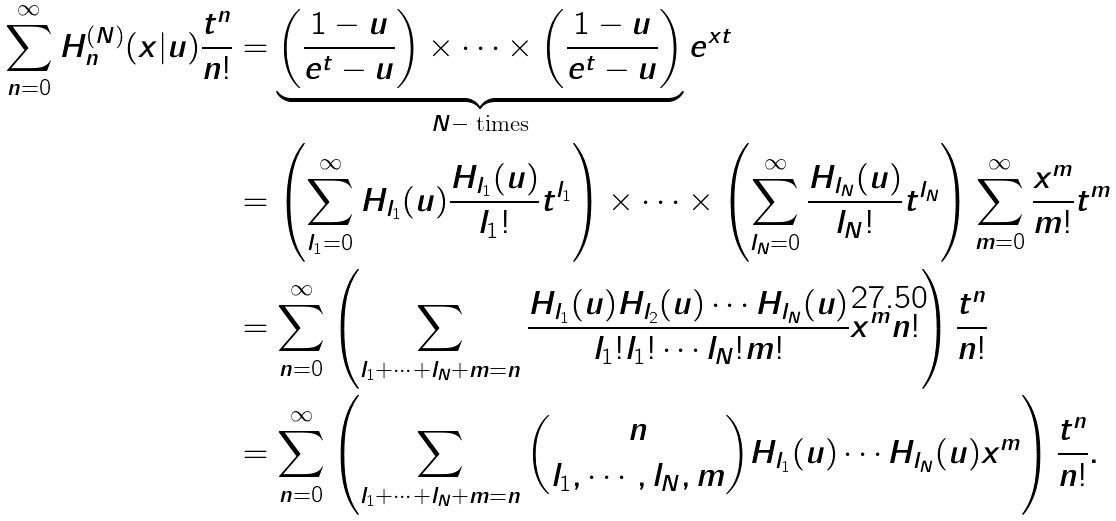Convert formula to latex. <formula><loc_0><loc_0><loc_500><loc_500>\sum _ { n = 0 } ^ { \infty } H _ { n } ^ { ( N ) } ( x | u ) \frac { t ^ { n } } { n ! } & = \underbrace { \left ( \frac { 1 - u } { e ^ { t } - u } \right ) \times \cdots \times \left ( \frac { 1 - u } { e ^ { t } - u } \right ) } _ { N - \text { times} } e ^ { x t } \\ & = \left ( \sum _ { l _ { 1 } = 0 } ^ { \infty } H _ { l _ { 1 } } ( u ) \frac { H _ { l _ { 1 } } ( u ) } { l _ { 1 } ! } t ^ { l _ { 1 } } \right ) \times \cdots \times \left ( \sum _ { l _ { N } = 0 } ^ { \infty } \frac { H _ { l _ { N } } ( u ) } { l _ { N } ! } t ^ { l _ { N } } \right ) \sum _ { m = 0 } ^ { \infty } \frac { x ^ { m } } { m ! } t ^ { m } \\ & = \sum _ { n = 0 } ^ { \infty } \left ( \sum _ { l _ { 1 } + \cdots + l _ { N } + m = n } \frac { H _ { l _ { 1 } } ( u ) H _ { l _ { 2 } } ( u ) \cdots H _ { l _ { N } } ( u ) } { l _ { 1 } ! l _ { 1 } ! \cdots l _ { N } ! m ! } x ^ { m } n ! \right ) \frac { t ^ { n } } { n ! } \\ & = \sum _ { n = 0 } ^ { \infty } \left ( \sum _ { l _ { 1 } + \cdots + l _ { N } + m = n } \binom { n } { l _ { 1 } , \cdots , l _ { N } , m } H _ { l _ { 1 } } ( u ) \cdots H _ { l _ { N } } ( u ) x ^ { m } \right ) \frac { t ^ { n } } { n ! } .</formula> 